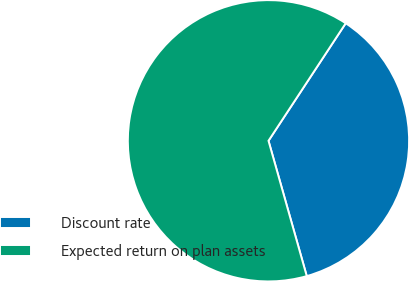Convert chart to OTSL. <chart><loc_0><loc_0><loc_500><loc_500><pie_chart><fcel>Discount rate<fcel>Expected return on plan assets<nl><fcel>36.36%<fcel>63.64%<nl></chart> 